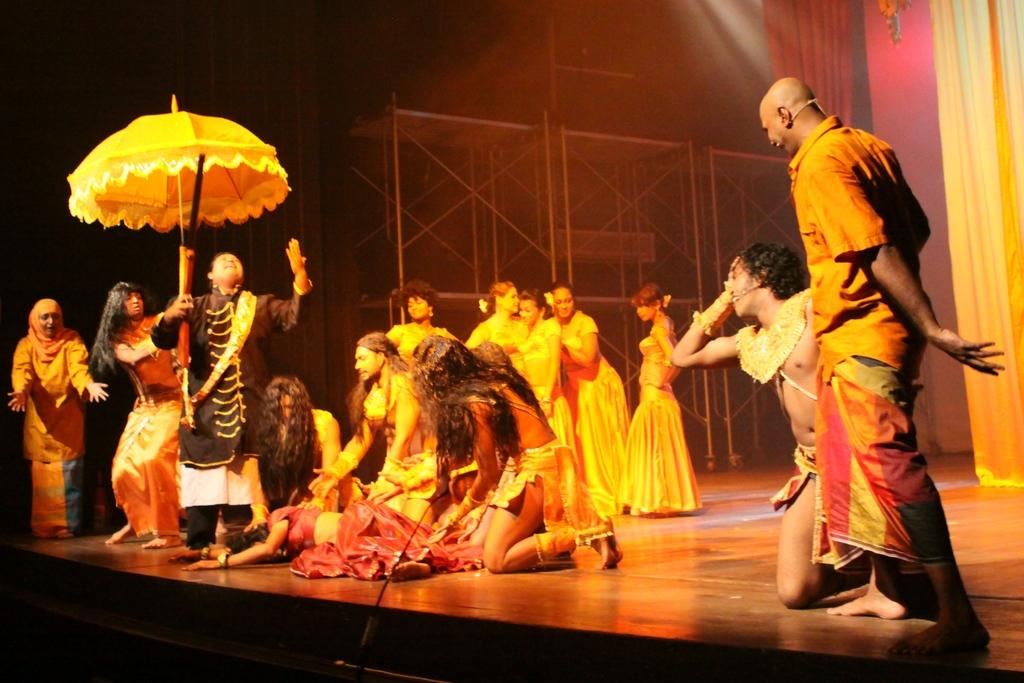What is happening on the stage in the image? There are people playing an act on the stage. What can be seen in the background of the image? There is a metal structure and curtains in the background. How many shops can be seen in the image? There are no shops visible in the image. What type of whistle is being used by the actors on the stage? There is no whistle present in the image; the people are playing an act without any whistles. 